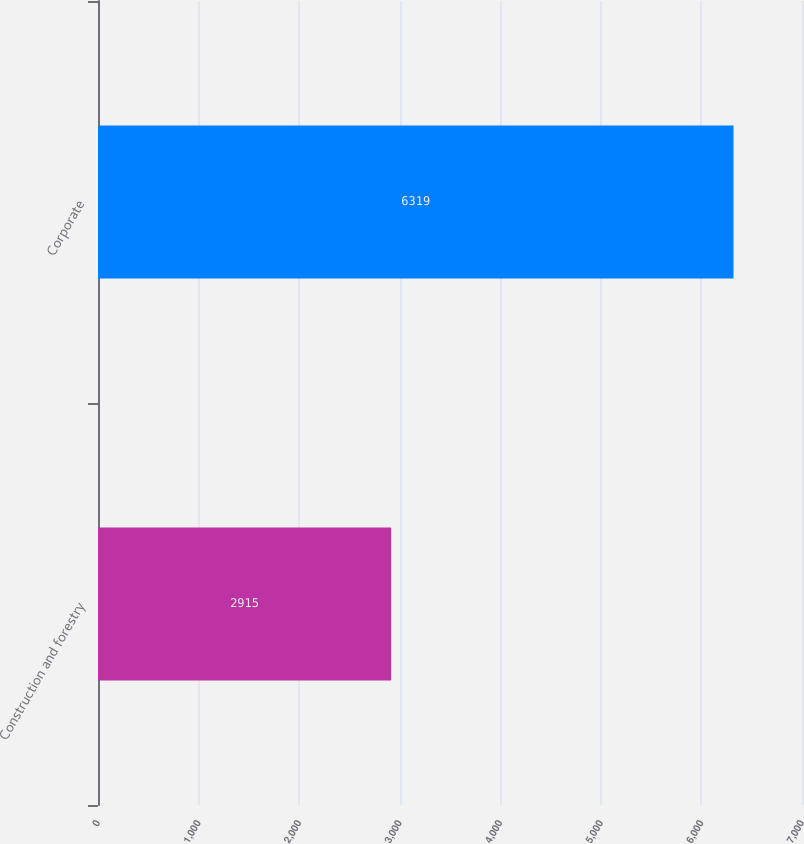Convert chart to OTSL. <chart><loc_0><loc_0><loc_500><loc_500><bar_chart><fcel>Construction and forestry<fcel>Corporate<nl><fcel>2915<fcel>6319<nl></chart> 